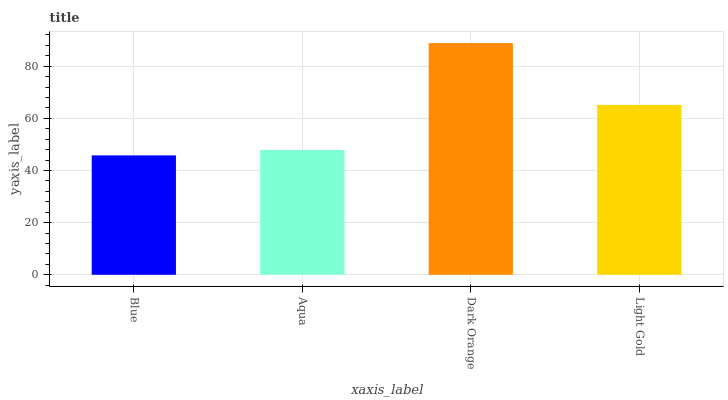Is Aqua the minimum?
Answer yes or no. No. Is Aqua the maximum?
Answer yes or no. No. Is Aqua greater than Blue?
Answer yes or no. Yes. Is Blue less than Aqua?
Answer yes or no. Yes. Is Blue greater than Aqua?
Answer yes or no. No. Is Aqua less than Blue?
Answer yes or no. No. Is Light Gold the high median?
Answer yes or no. Yes. Is Aqua the low median?
Answer yes or no. Yes. Is Blue the high median?
Answer yes or no. No. Is Dark Orange the low median?
Answer yes or no. No. 